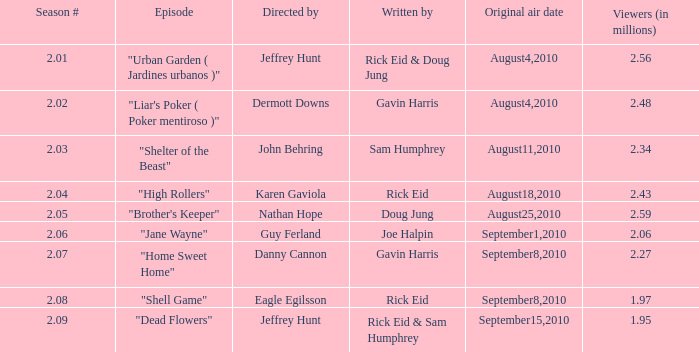08, who was the episode's writer? Rick Eid. 